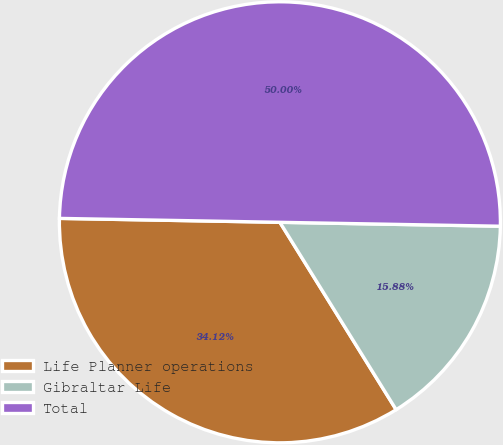Convert chart. <chart><loc_0><loc_0><loc_500><loc_500><pie_chart><fcel>Life Planner operations<fcel>Gibraltar Life<fcel>Total<nl><fcel>34.12%<fcel>15.88%<fcel>50.0%<nl></chart> 